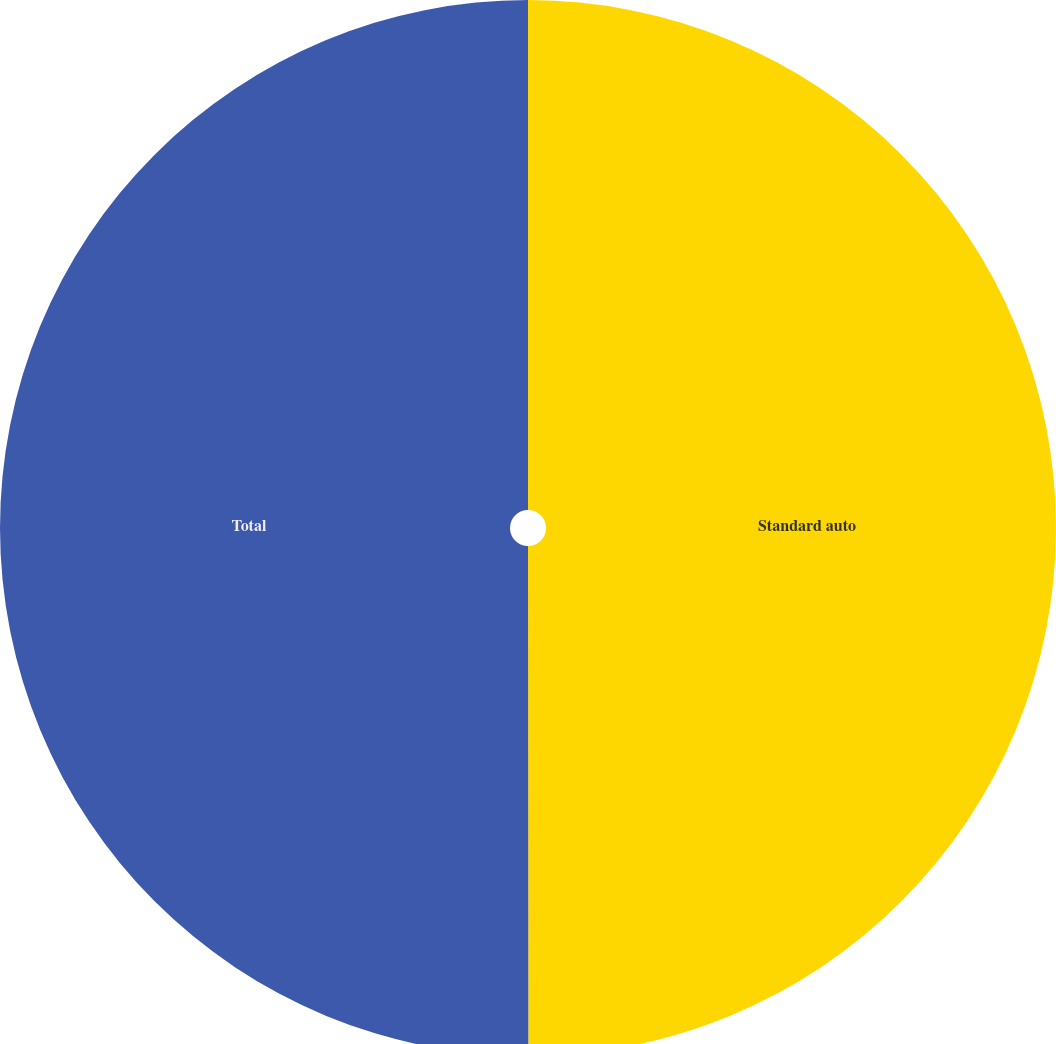Convert chart. <chart><loc_0><loc_0><loc_500><loc_500><pie_chart><fcel>Standard auto<fcel>Total<nl><fcel>49.99%<fcel>50.01%<nl></chart> 